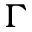Convert formula to latex. <formula><loc_0><loc_0><loc_500><loc_500>\Gamma</formula> 